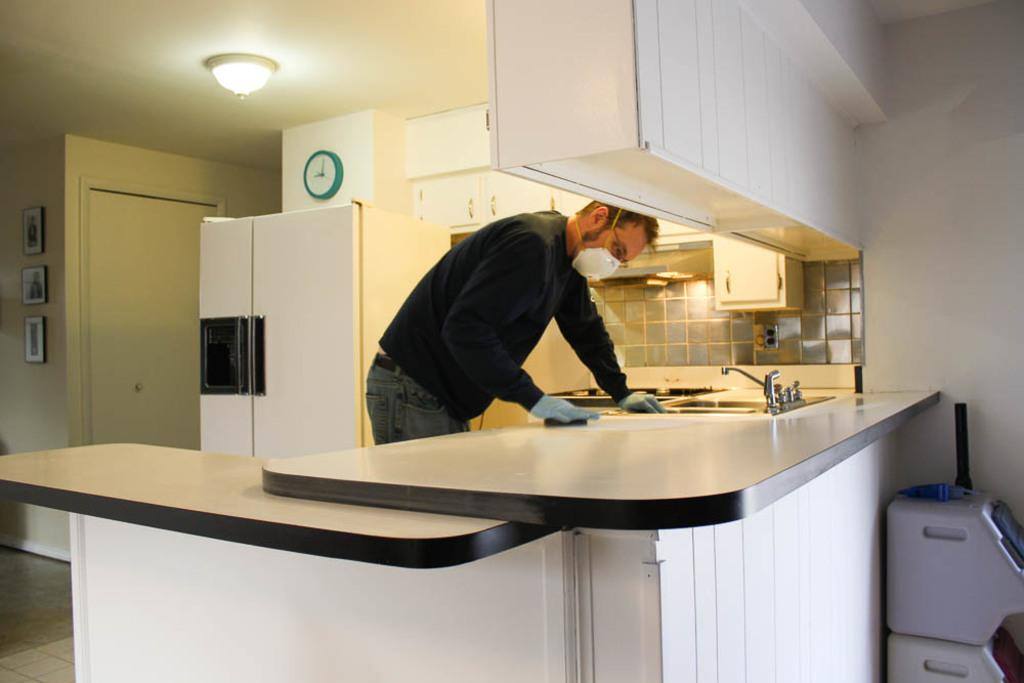What is the person in the image doing? The person is standing in front of a table. What other large object can be seen in the image? There is a refrigerator visible in the image. What decorative items are on the wall? There are frames on the wall. What provides illumination in the image? There is a light on the roof. How many people are in the crowd depicted in the image? There is no crowd present in the image; it only shows a person standing in front of a table. 